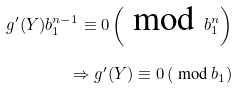Convert formula to latex. <formula><loc_0><loc_0><loc_500><loc_500>g ^ { \prime } ( Y ) { b _ { 1 } ^ { n - 1 } } \equiv 0 \left ( \text { mod } b _ { 1 } ^ { n } \right ) \\ \Rightarrow g ^ { \prime } ( Y ) \equiv 0 \left ( \text { mod } b _ { 1 } \right )</formula> 